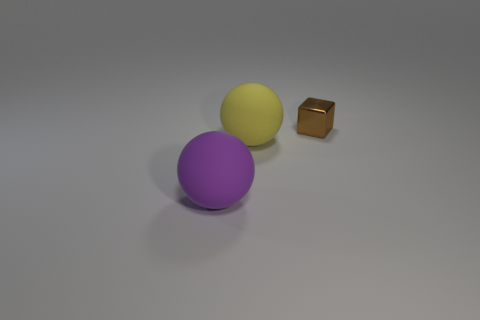Add 2 brown matte spheres. How many objects exist? 5 Subtract 2 balls. How many balls are left? 0 Add 3 tiny red balls. How many tiny red balls exist? 3 Subtract all purple spheres. How many spheres are left? 1 Subtract 0 cyan spheres. How many objects are left? 3 Subtract all cubes. How many objects are left? 2 Subtract all purple balls. Subtract all blue cylinders. How many balls are left? 1 Subtract all blue balls. How many green cubes are left? 0 Subtract all tiny yellow shiny blocks. Subtract all metal cubes. How many objects are left? 2 Add 1 spheres. How many spheres are left? 3 